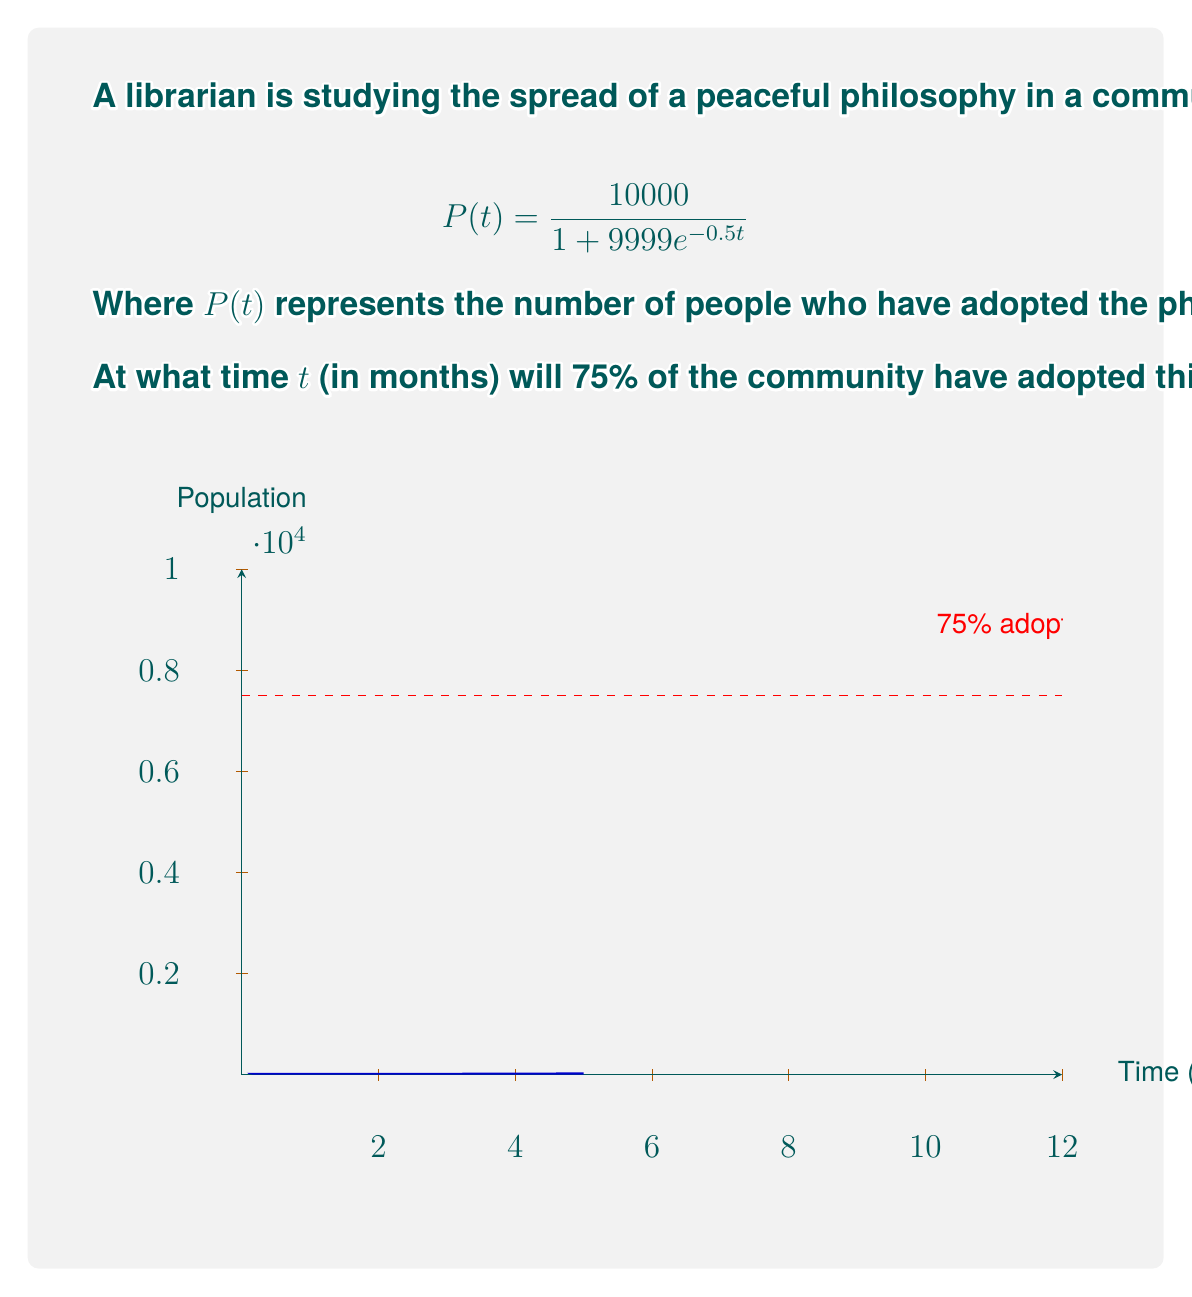Teach me how to tackle this problem. Let's approach this step-by-step:

1) We want to find $t$ when $P(t) = 75\%$ of 10,000, which is 7,500.

2) We can set up the equation:

   $$7500 = \frac{10000}{1 + 9999e^{-0.5t}}$$

3) Multiply both sides by $(1 + 9999e^{-0.5t})$:

   $$7500(1 + 9999e^{-0.5t}) = 10000$$

4) Distribute on the left side:

   $$7500 + 74992500e^{-0.5t} = 10000$$

5) Subtract 7500 from both sides:

   $$74992500e^{-0.5t} = 2500$$

6) Divide both sides by 74992500:

   $$e^{-0.5t} = \frac{1}{29997}$$

7) Take the natural log of both sides:

   $$-0.5t = \ln(\frac{1}{29997})$$

8) Divide both sides by -0.5:

   $$t = -\frac{2}{0.5}\ln(\frac{1}{29997}) = 2\ln(29997)$$

9) Calculate and round to the nearest tenth:

   $$t \approx 20.7$$

Therefore, it will take approximately 20.7 months for 75% of the community to adopt the peaceful philosophy.
Answer: 20.7 months 